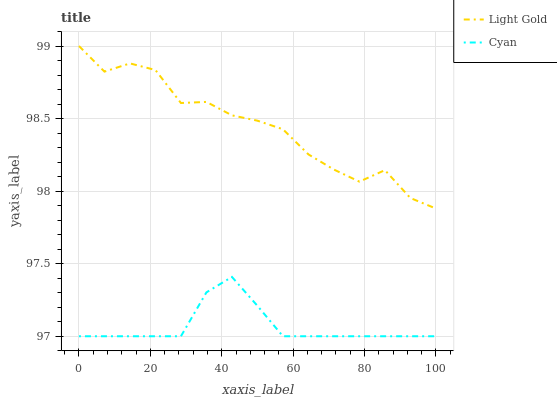Does Cyan have the minimum area under the curve?
Answer yes or no. Yes. Does Light Gold have the maximum area under the curve?
Answer yes or no. Yes. Does Light Gold have the minimum area under the curve?
Answer yes or no. No. Is Cyan the smoothest?
Answer yes or no. Yes. Is Light Gold the roughest?
Answer yes or no. Yes. Is Light Gold the smoothest?
Answer yes or no. No. Does Light Gold have the lowest value?
Answer yes or no. No. Does Light Gold have the highest value?
Answer yes or no. Yes. Is Cyan less than Light Gold?
Answer yes or no. Yes. Is Light Gold greater than Cyan?
Answer yes or no. Yes. Does Cyan intersect Light Gold?
Answer yes or no. No. 